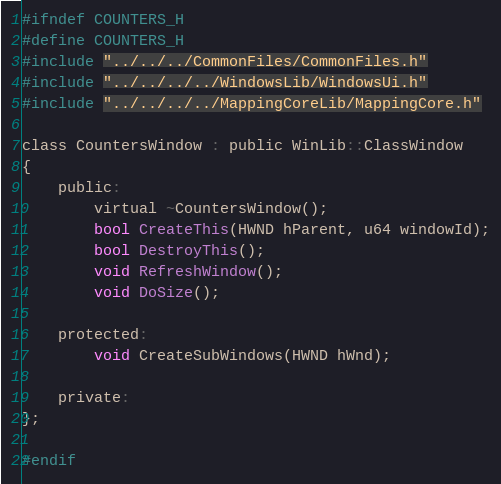Convert code to text. <code><loc_0><loc_0><loc_500><loc_500><_C_>#ifndef COUNTERS_H
#define COUNTERS_H
#include "../../../CommonFiles/CommonFiles.h"
#include "../../../../WindowsLib/WindowsUi.h"
#include "../../../../MappingCoreLib/MappingCore.h"

class CountersWindow : public WinLib::ClassWindow
{
    public:
        virtual ~CountersWindow();
        bool CreateThis(HWND hParent, u64 windowId);
        bool DestroyThis();
        void RefreshWindow();
        void DoSize();

    protected:
        void CreateSubWindows(HWND hWnd);

    private:
};

#endif</code> 